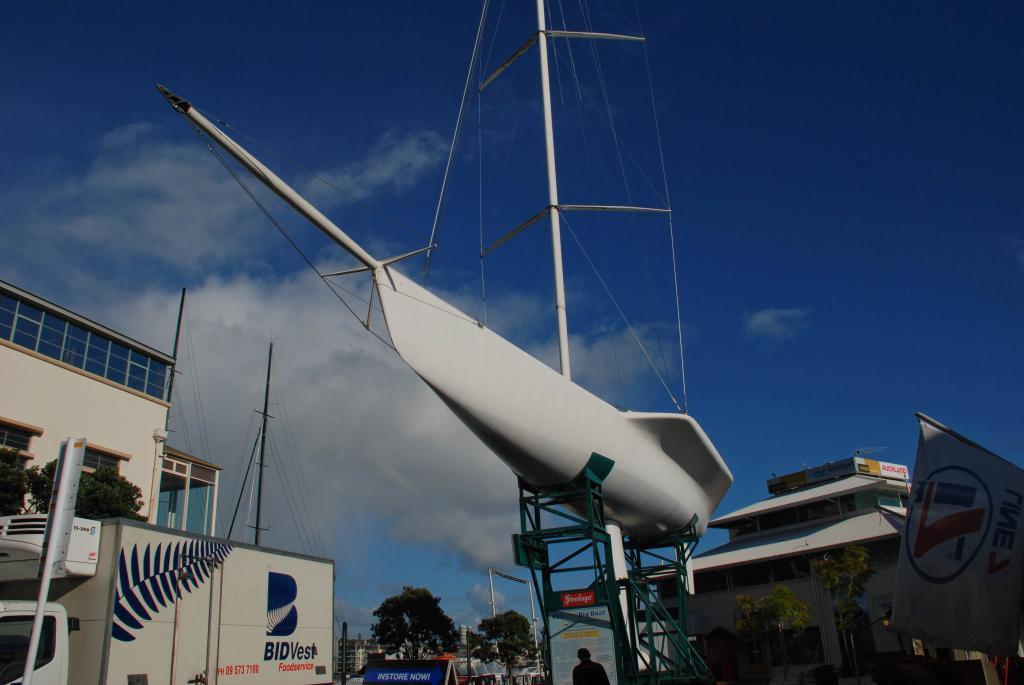Can you describe this image briefly? In this picture we can see a few vehicles, buildings, trees and a white object. We can see a banner on the right side. Sky is blue in color and cloudy. 